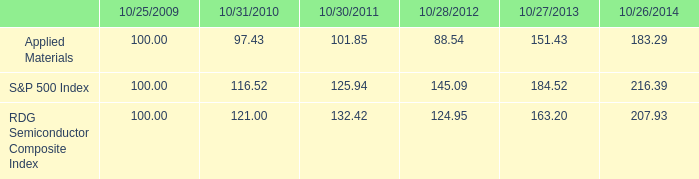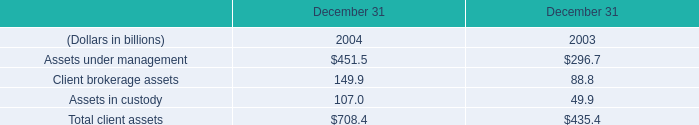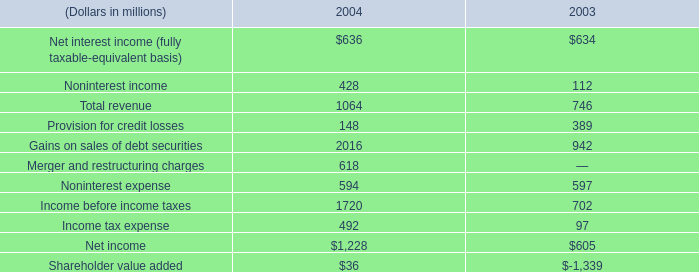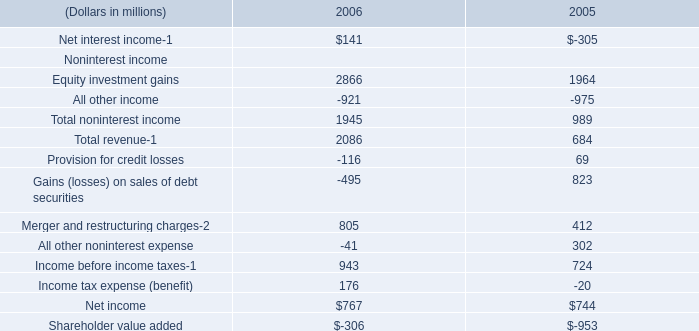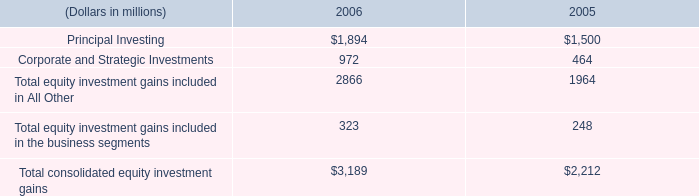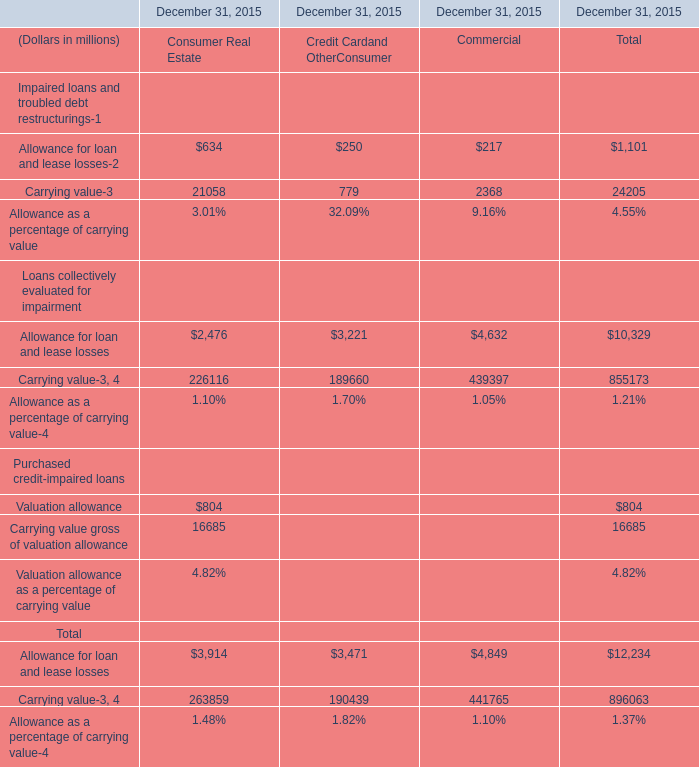What is the sum of Income before income taxes of 2004, and Carrying value of December 31, 2015 Consumer Real Estate ? 
Computations: (1720.0 + 21058.0)
Answer: 22778.0. 